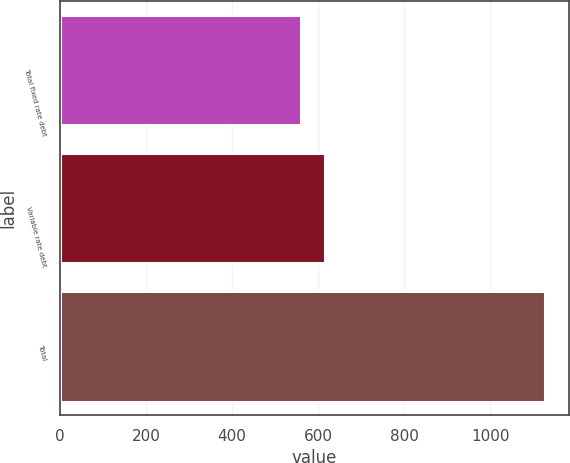Convert chart to OTSL. <chart><loc_0><loc_0><loc_500><loc_500><bar_chart><fcel>Total fixed rate debt<fcel>Variable rate debt<fcel>Total<nl><fcel>559<fcel>615.7<fcel>1126<nl></chart> 